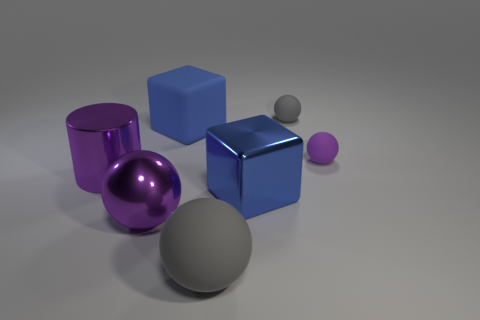What material is the big ball that is the same color as the cylinder?
Offer a very short reply. Metal. Is the shape of the tiny gray rubber thing the same as the blue shiny object?
Provide a short and direct response. No. What number of other things are the same color as the metallic sphere?
Your answer should be very brief. 2. What number of brown objects are either large cubes or big matte cylinders?
Offer a terse response. 0. What color is the rubber thing that is behind the big shiny cylinder and left of the big metal block?
Your answer should be compact. Blue. What number of small things are shiny blocks or cyan metallic balls?
Ensure brevity in your answer.  0. The other gray matte object that is the same shape as the small gray thing is what size?
Provide a short and direct response. Large. What is the shape of the blue shiny object?
Provide a short and direct response. Cube. Is the big gray thing made of the same material as the purple ball in front of the large cylinder?
Your response must be concise. No. What number of matte objects are either blue objects or small things?
Your response must be concise. 3. 